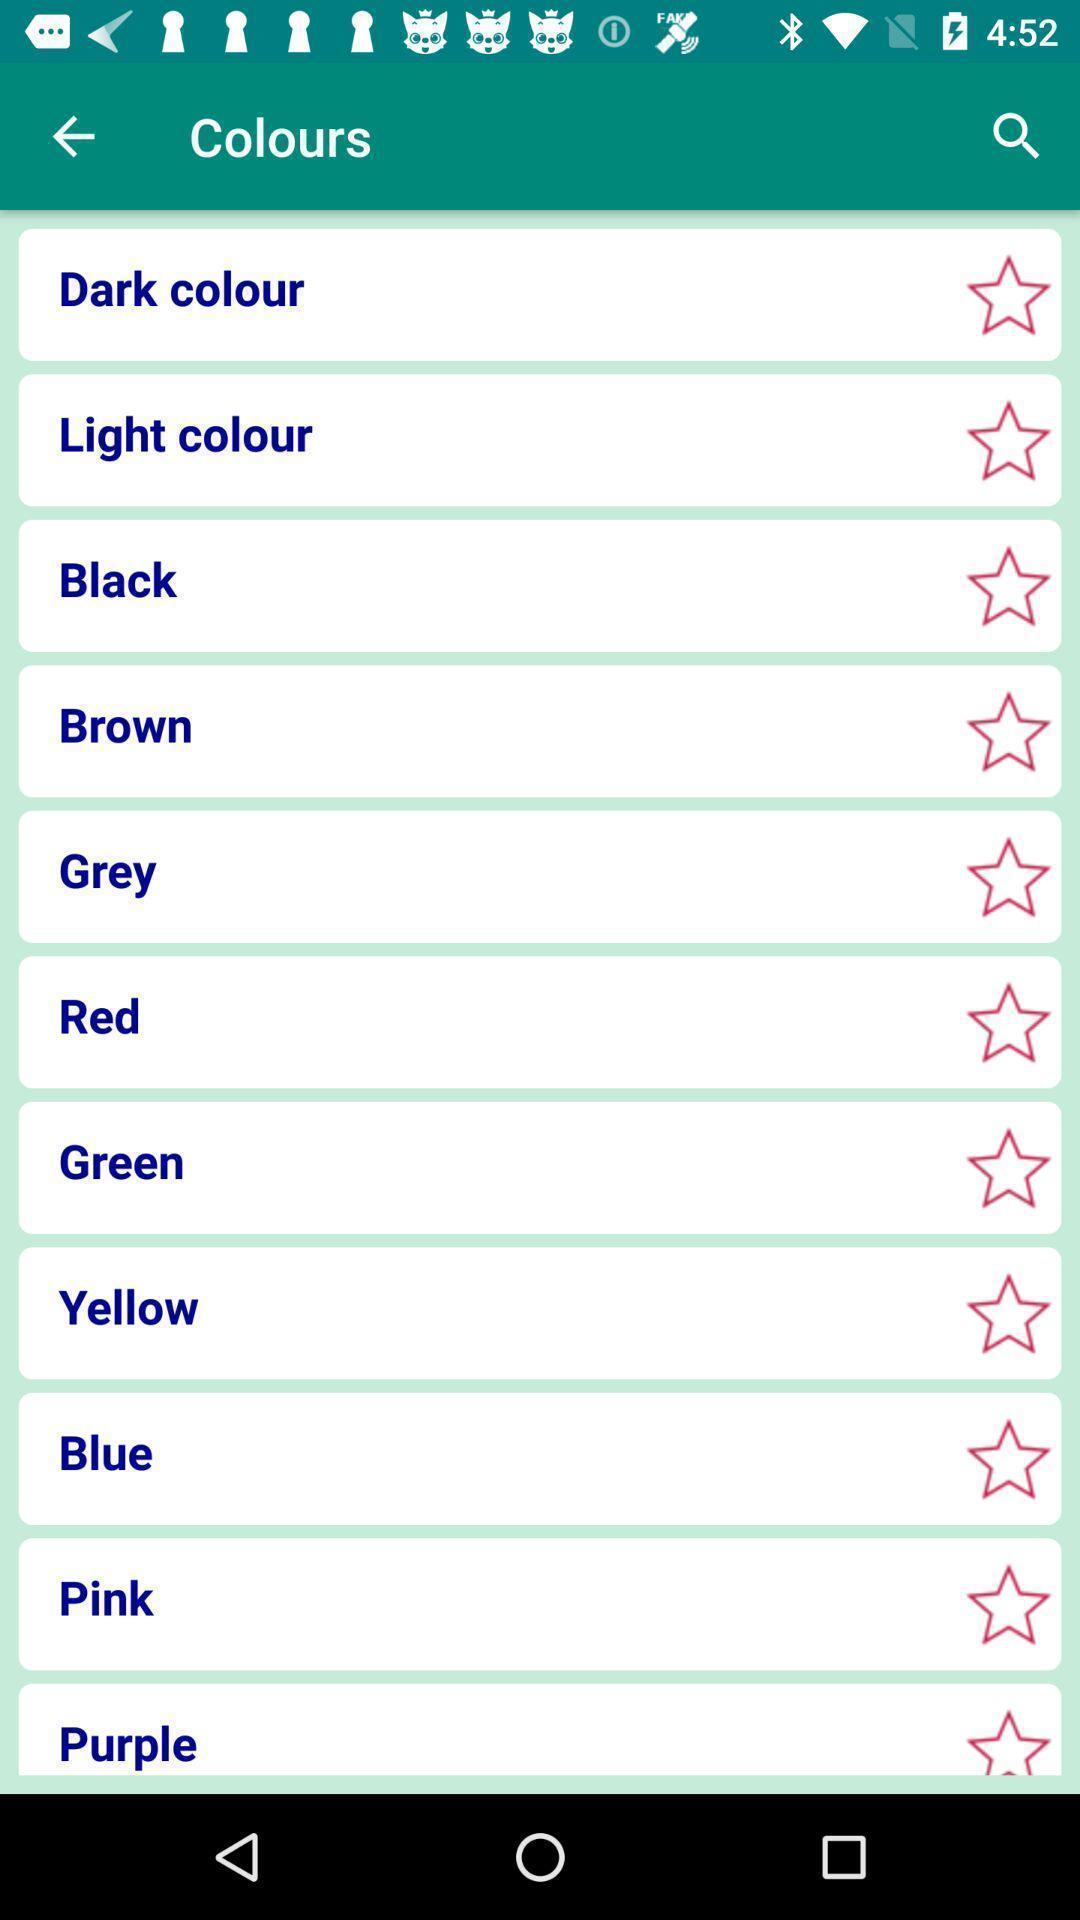Tell me about the visual elements in this screen capture. Screen displaying the list of colours. 